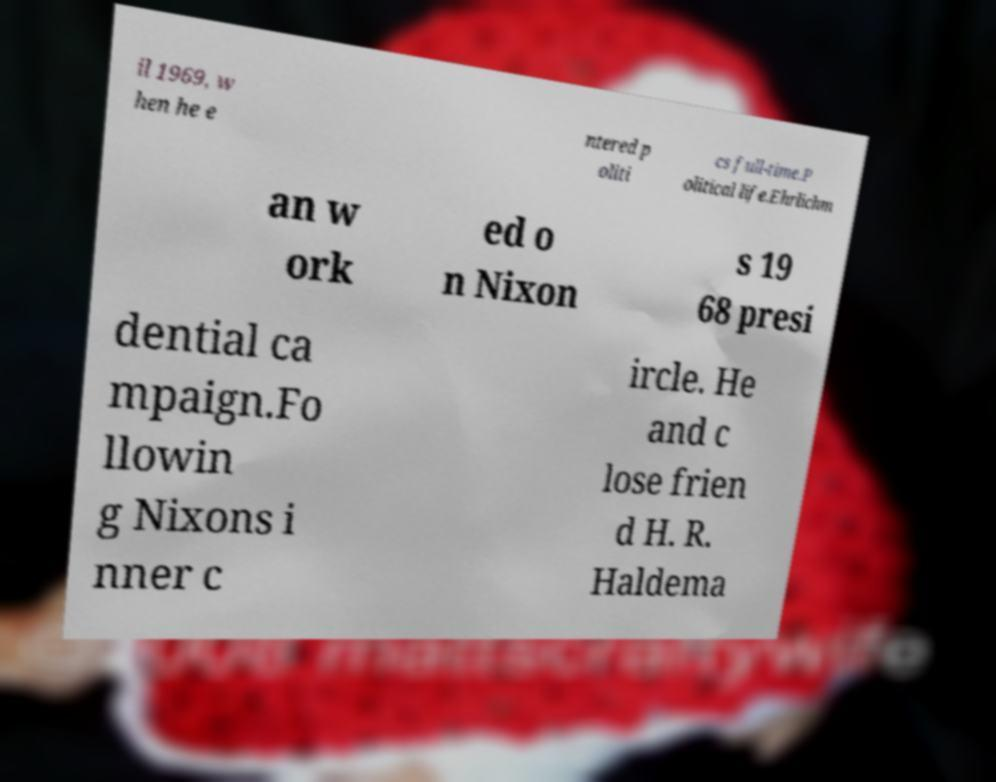Could you extract and type out the text from this image? il 1969, w hen he e ntered p oliti cs full-time.P olitical life.Ehrlichm an w ork ed o n Nixon s 19 68 presi dential ca mpaign.Fo llowin g Nixons i nner c ircle. He and c lose frien d H. R. Haldema 